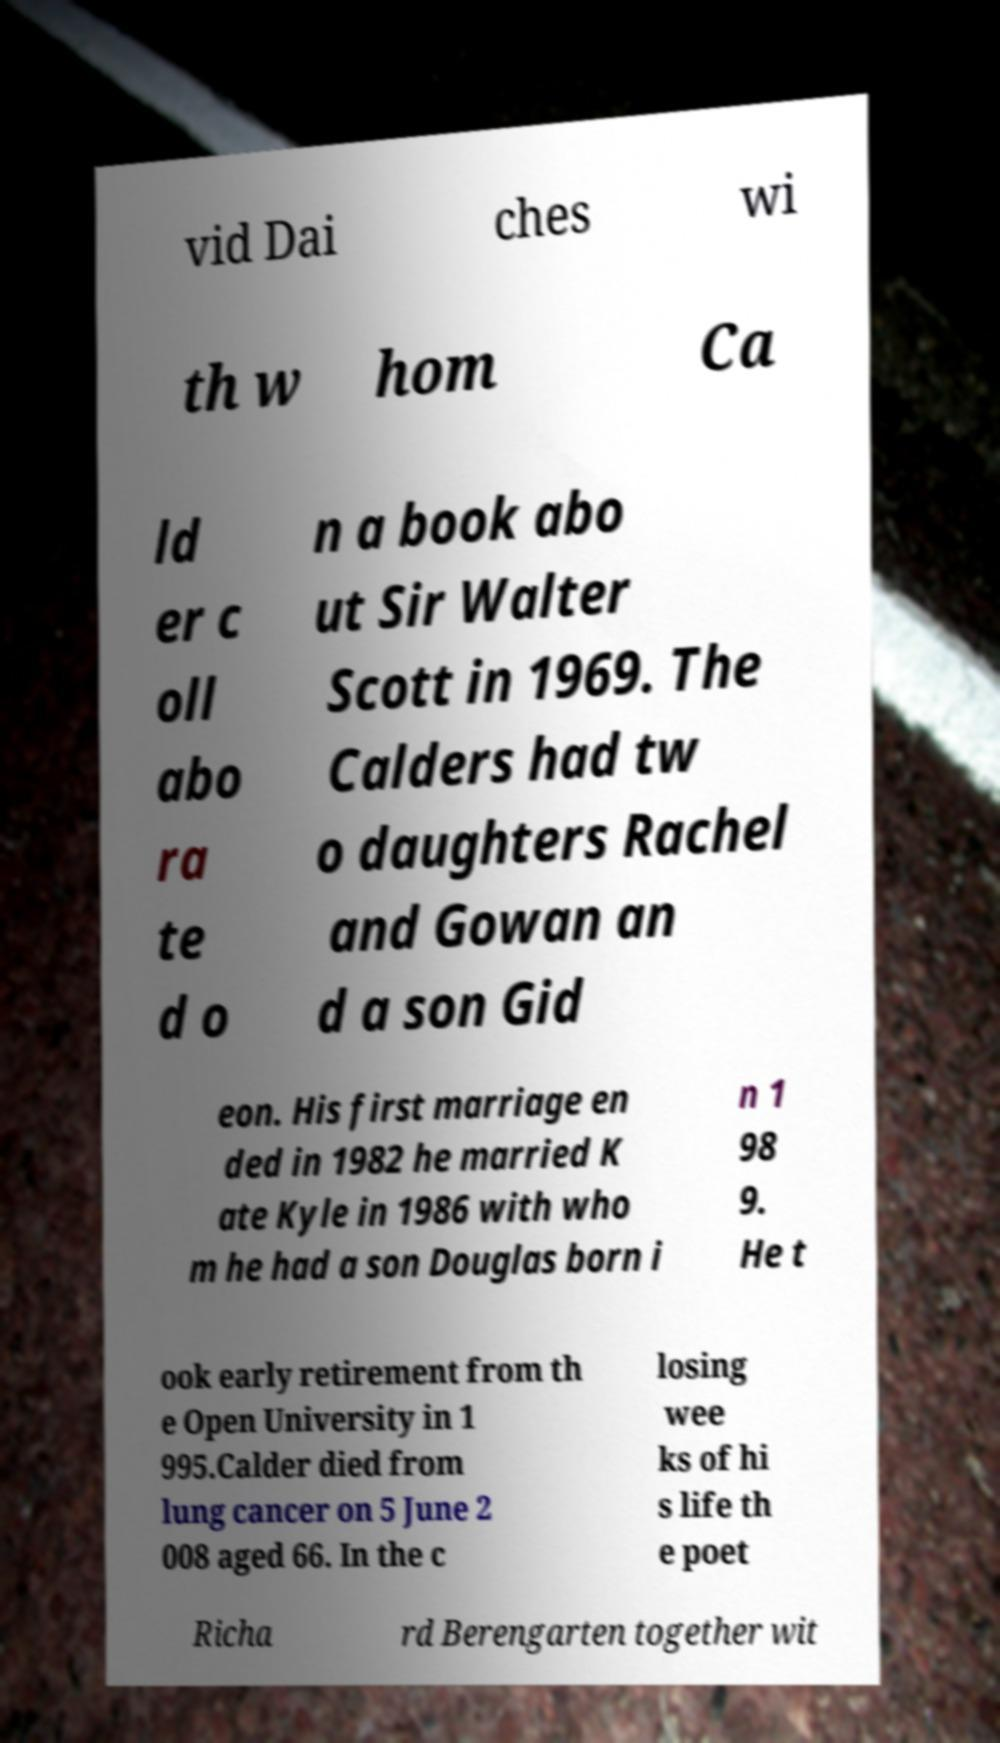Please identify and transcribe the text found in this image. vid Dai ches wi th w hom Ca ld er c oll abo ra te d o n a book abo ut Sir Walter Scott in 1969. The Calders had tw o daughters Rachel and Gowan an d a son Gid eon. His first marriage en ded in 1982 he married K ate Kyle in 1986 with who m he had a son Douglas born i n 1 98 9. He t ook early retirement from th e Open University in 1 995.Calder died from lung cancer on 5 June 2 008 aged 66. In the c losing wee ks of hi s life th e poet Richa rd Berengarten together wit 